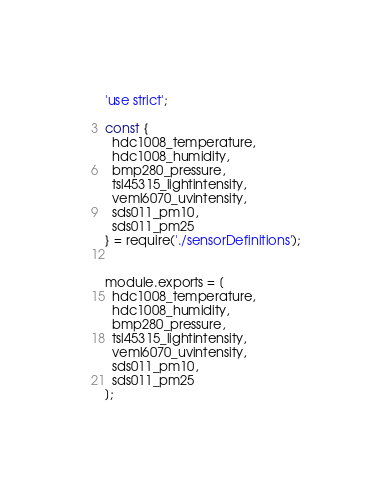<code> <loc_0><loc_0><loc_500><loc_500><_JavaScript_>'use strict';

const {
  hdc1008_temperature,
  hdc1008_humidity,
  bmp280_pressure,
  tsl45315_lightintensity,
  veml6070_uvintensity,
  sds011_pm10,
  sds011_pm25
} = require('./sensorDefinitions');


module.exports = [
  hdc1008_temperature,
  hdc1008_humidity,
  bmp280_pressure,
  tsl45315_lightintensity,
  veml6070_uvintensity,
  sds011_pm10,
  sds011_pm25
];
</code> 